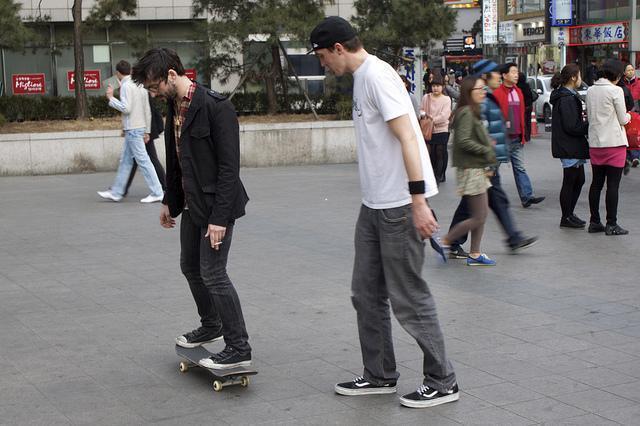How many people are there?
Give a very brief answer. 9. How many chair legs are touching only the orange surface of the floor?
Give a very brief answer. 0. 